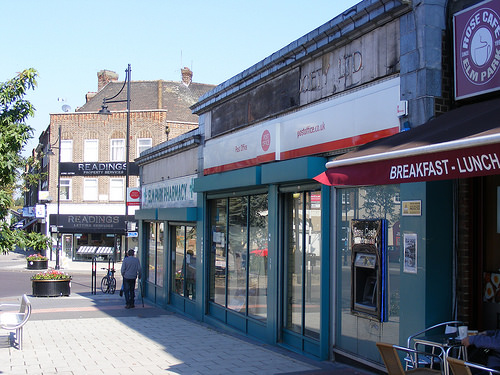<image>
Is there a man in the store? No. The man is not contained within the store. These objects have a different spatial relationship. 